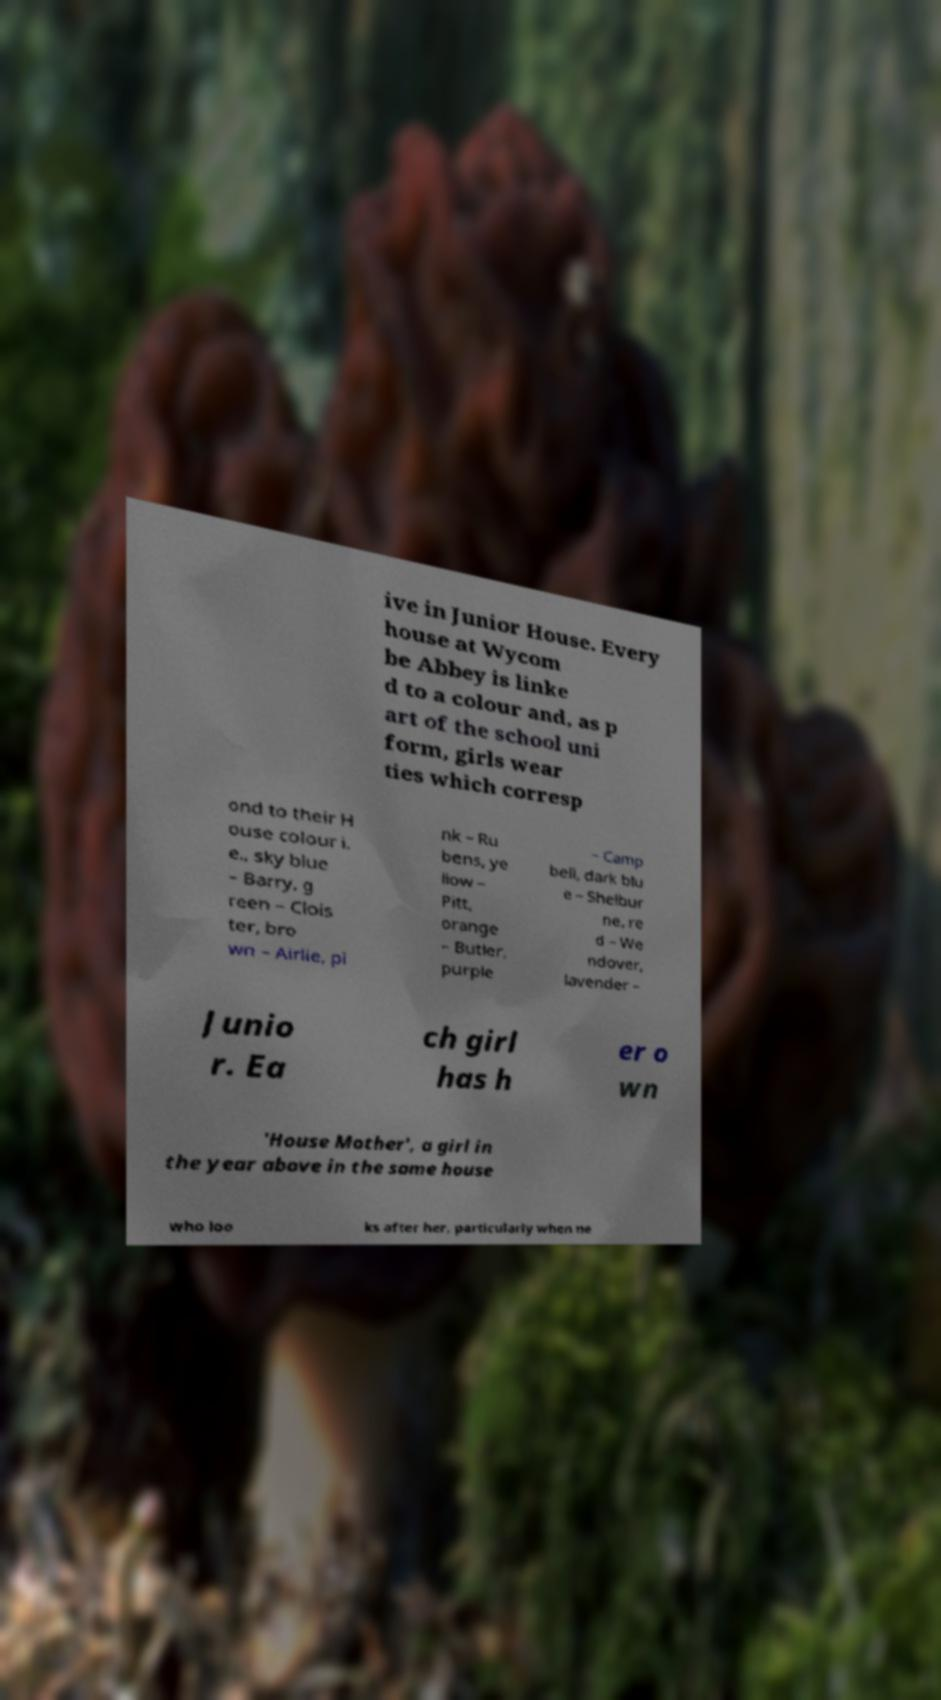I need the written content from this picture converted into text. Can you do that? ive in Junior House. Every house at Wycom be Abbey is linke d to a colour and, as p art of the school uni form, girls wear ties which corresp ond to their H ouse colour i. e., sky blue – Barry, g reen – Clois ter, bro wn – Airlie, pi nk – Ru bens, ye llow – Pitt, orange – Butler, purple – Camp bell, dark blu e – Shelbur ne, re d – We ndover, lavender – Junio r. Ea ch girl has h er o wn 'House Mother', a girl in the year above in the same house who loo ks after her, particularly when ne 